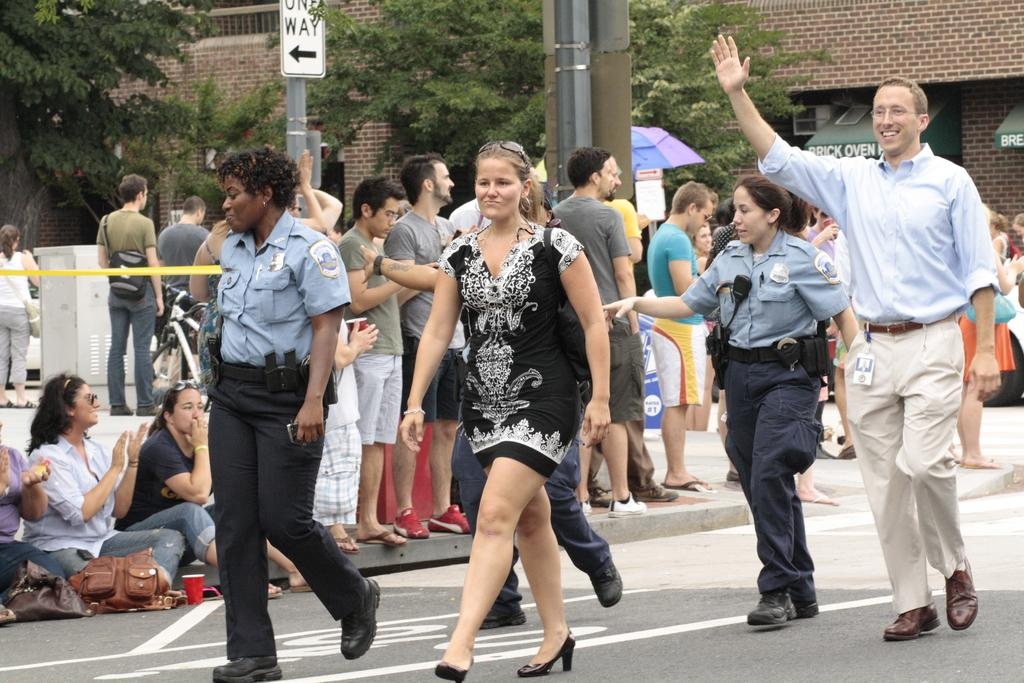What are the people in the image doing? There are persons standing on the road and sitting on the footpath. What can be seen in the background of the image? In the background, there are sign boards, poles, an umbrella, trees, and buildings. What type of leaf is being used as a prop in the army's training exercise in the image? There is no leaf or army present in the image; it features persons standing and sitting on a road and footpath, with various background elements. 